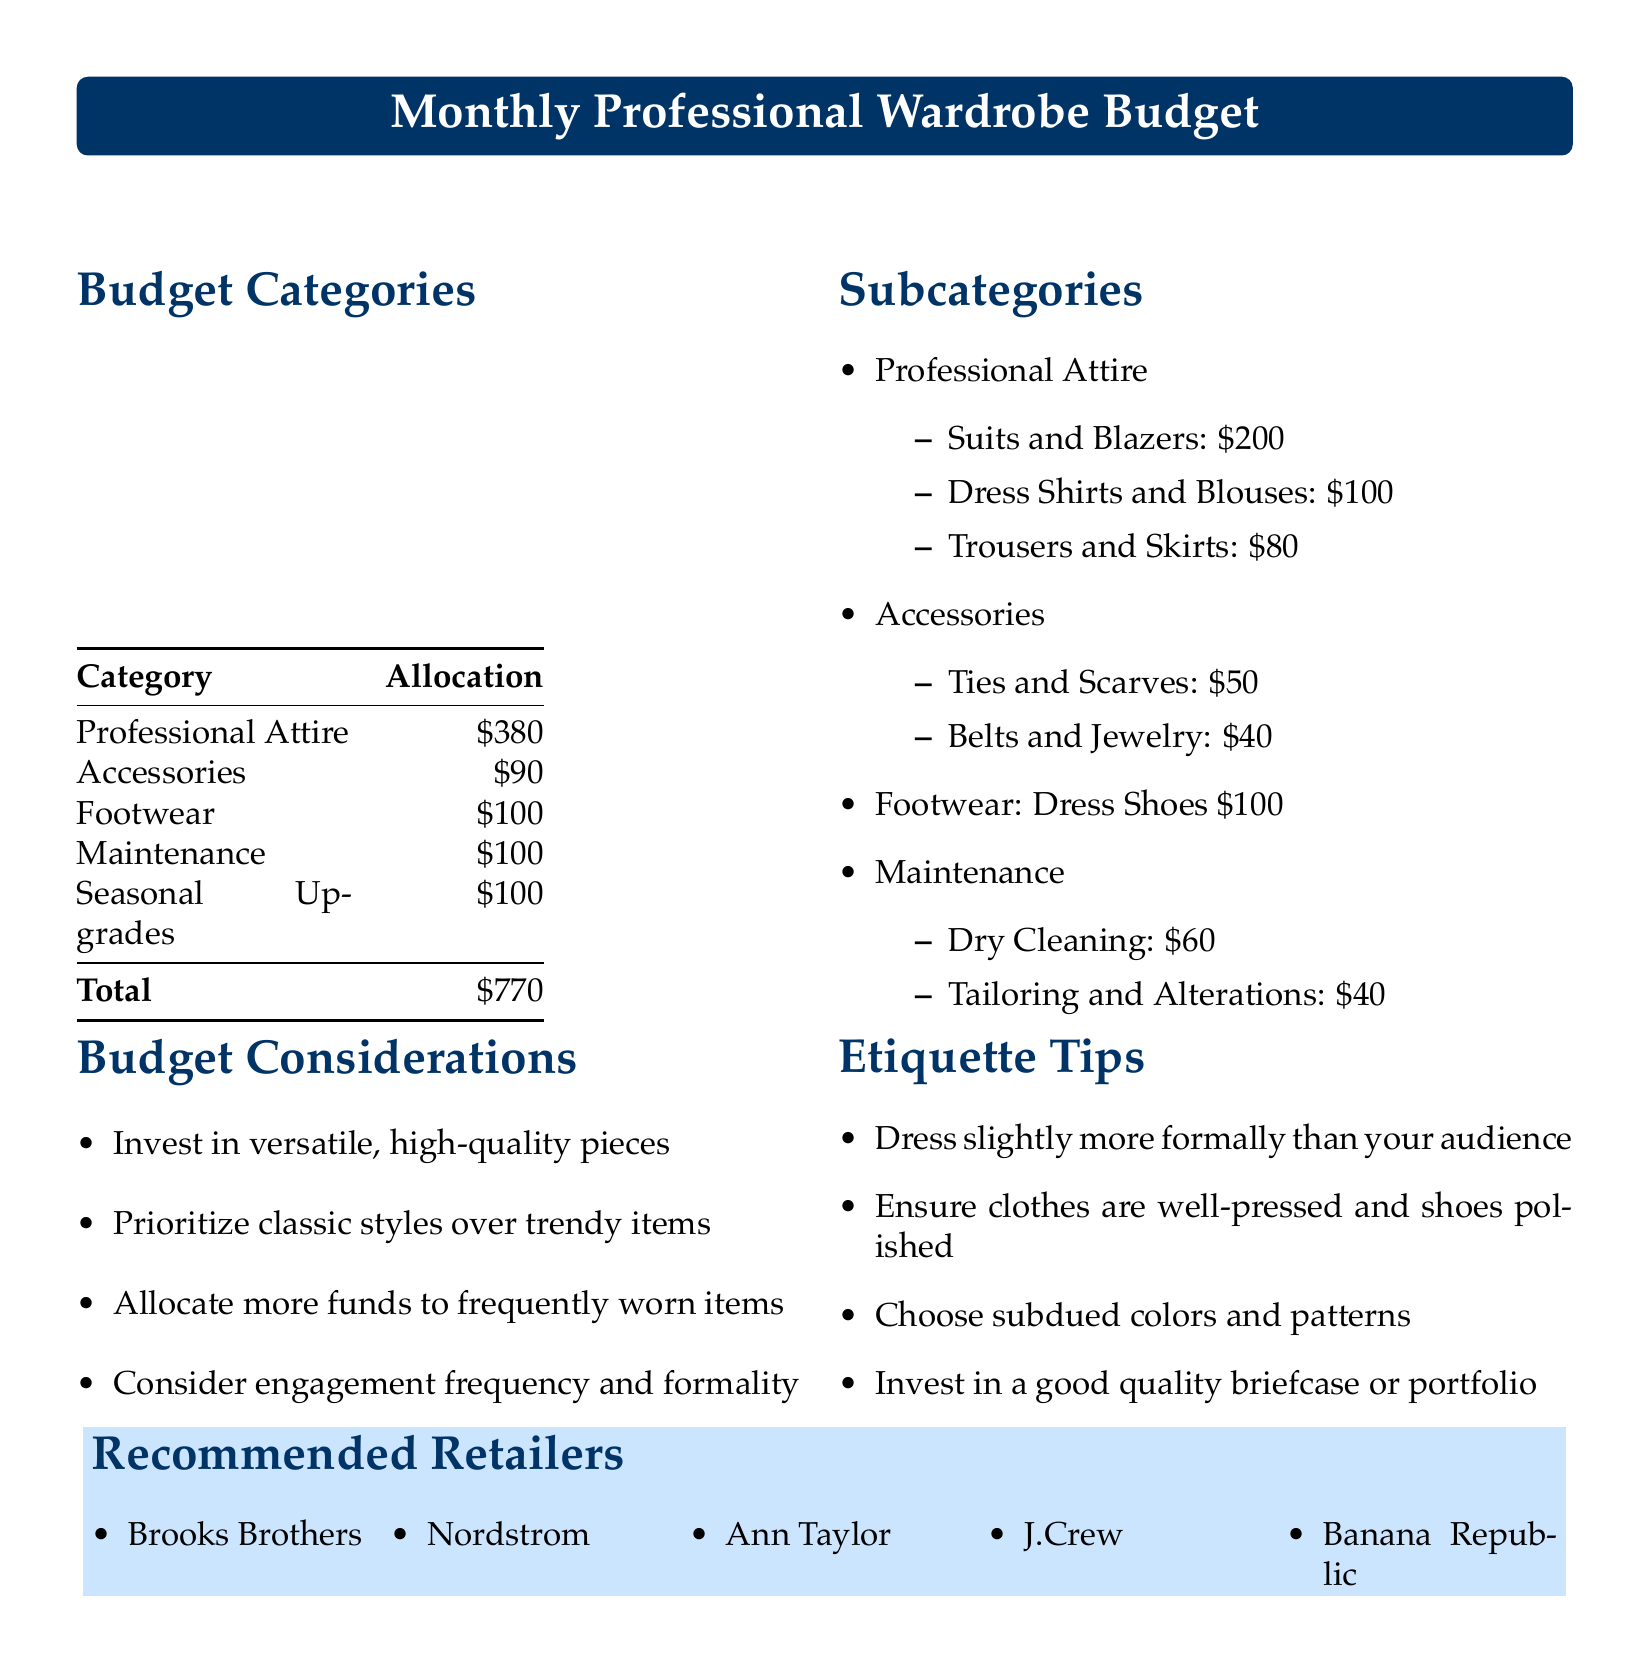What is the total budget allocation? The total budget allocation is the sum of all categories listed in the document. The sum is $380 + $90 + $100 + $100 + $100 = $770.
Answer: $770 How much is allocated for Professional Attire? The allocation for Professional Attire is clearly stated in the document under Budget Categories.
Answer: $380 What is the allocation for Accessories? The amount allocated for Accessories is specified in the budget categories section of the document.
Answer: $90 What item is covered under Maintenance and its allocation? The document specifies that Dry Cleaning and Tailoring are part of Maintenance, along with their respective costs.
Answer: \$60 for Dry Cleaning, \$40 for Tailoring What should be prioritized according to the Budget Considerations? The document suggests prioritizing certain elements for the wardrobe.
Answer: Classic styles over trendy items What does the etiquette tip suggest about dressing relative to the audience? One of the etiquette tips provided gives advice on how to dress for events in relation to the audience.
Answer: Dress slightly more formally than your audience Which retailer is listed first in the Recommended Retailers? The first retailer mentioned in the list of Recommended Retailers can be directly found in the document.
Answer: Brooks Brothers How much is budgeted for Seasonal Upgrades? The document specifies an amount allocated specifically for Seasonal Upgrades.
Answer: $100 What is the budget allocation for Footwear? The Footwear section of the budget clearly states its allocation.
Answer: $100 